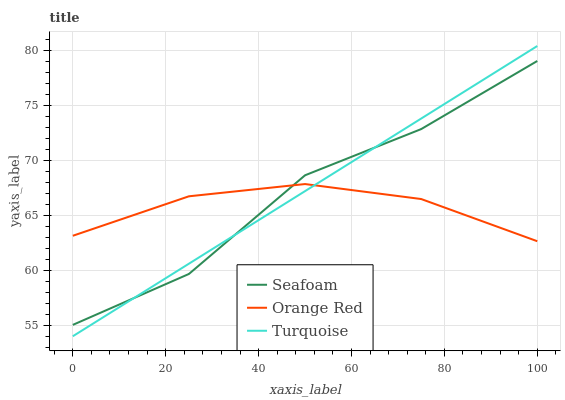Does Orange Red have the minimum area under the curve?
Answer yes or no. Yes. Does Turquoise have the maximum area under the curve?
Answer yes or no. Yes. Does Seafoam have the minimum area under the curve?
Answer yes or no. No. Does Seafoam have the maximum area under the curve?
Answer yes or no. No. Is Turquoise the smoothest?
Answer yes or no. Yes. Is Seafoam the roughest?
Answer yes or no. Yes. Is Orange Red the smoothest?
Answer yes or no. No. Is Orange Red the roughest?
Answer yes or no. No. Does Seafoam have the lowest value?
Answer yes or no. No. Does Turquoise have the highest value?
Answer yes or no. Yes. Does Seafoam have the highest value?
Answer yes or no. No. Does Seafoam intersect Turquoise?
Answer yes or no. Yes. Is Seafoam less than Turquoise?
Answer yes or no. No. Is Seafoam greater than Turquoise?
Answer yes or no. No. 